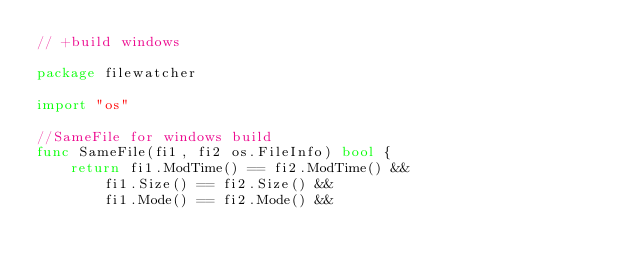<code> <loc_0><loc_0><loc_500><loc_500><_Go_>// +build windows

package filewatcher

import "os"

//SameFile for windows build
func SameFile(fi1, fi2 os.FileInfo) bool {
	return fi1.ModTime() == fi2.ModTime() &&
		fi1.Size() == fi2.Size() &&
		fi1.Mode() == fi2.Mode() &&</code> 